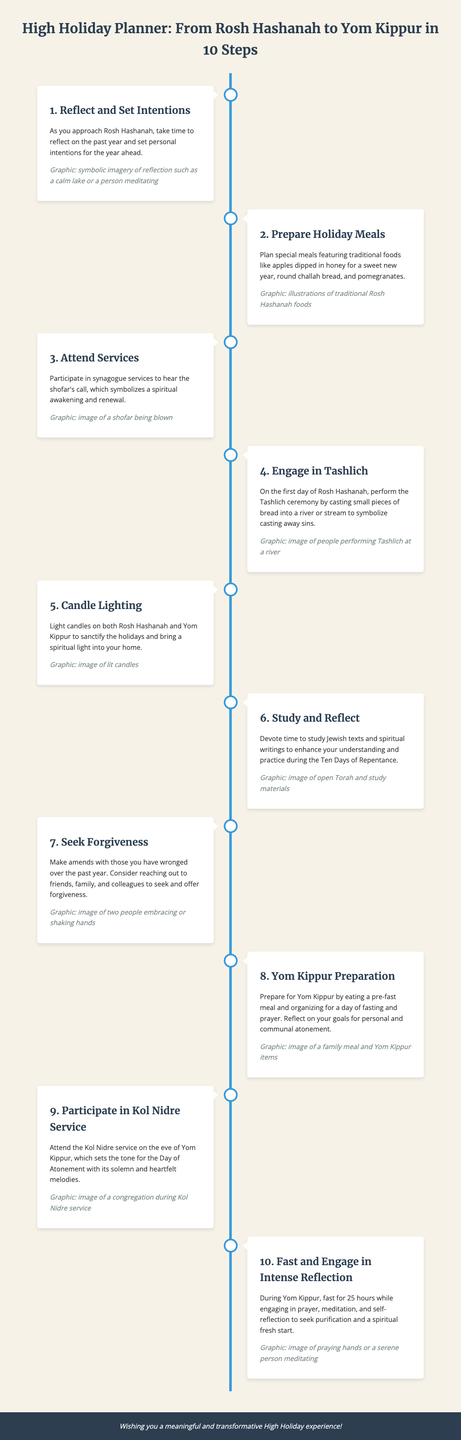What is the title of the infographic? The title is clearly stated at the top of the infographic and summarizes the content.
Answer: High Holiday Planner: From Rosh Hashanah to Yom Kippur in 10 Steps How many steps are outlined in the infographic? The infographic explicitly lists the steps from 1 to 10 in its timeline.
Answer: 10 Which traditional food is mentioned for Rosh Hashanah? The infographic mentions specific traditional foods in the meal preparation section.
Answer: Apples dipped in honey What ceremony involves casting away sins? The infographic describes a specific ceremony that symbolizes casting away sins, and it is highlighted in Step 4.
Answer: Tashlich During which service is the tone set for Yom Kippur? The infographic specifies the service that takes place on the eve of Yom Kippur, which is vital for setting its solemnity.
Answer: Kol Nidre Service What is the main activity suggested for Yom Kippur? The infographic outlines the key focus for Yom Kippur as indicated in the last step.
Answer: Fast and Engage in Intense Reflection What is suggested to be prepared before Yom Kippur? The infographic recommends a specific pre-fast activity in preparation for Yom Kippur.
Answer: Pre-fast meal Which Jewish tradition is associated with lighting candles? The infographic connects a specific ritual involving candles with both holidays mentioned.
Answer: Candle Lighting 